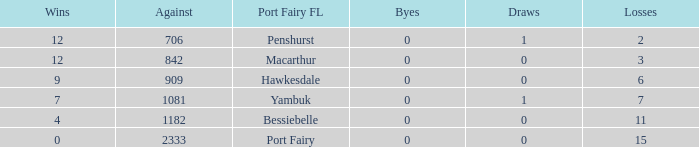How many wins for Port Fairy and against more than 2333? None. 